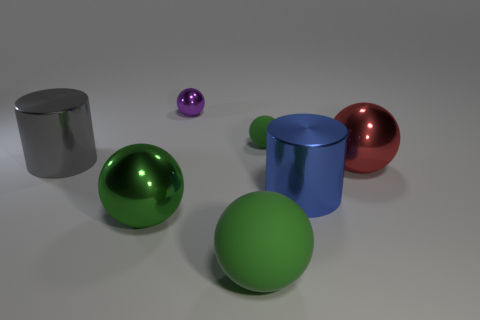Subtract all yellow cylinders. How many green balls are left? 3 Subtract 1 spheres. How many spheres are left? 4 Subtract all red balls. How many balls are left? 4 Subtract all big green metallic balls. How many balls are left? 4 Subtract all gray balls. Subtract all blue cylinders. How many balls are left? 5 Add 2 tiny spheres. How many objects exist? 9 Subtract all cylinders. How many objects are left? 5 Add 4 big objects. How many big objects are left? 9 Add 2 big gray metal things. How many big gray metal things exist? 3 Subtract 0 cyan balls. How many objects are left? 7 